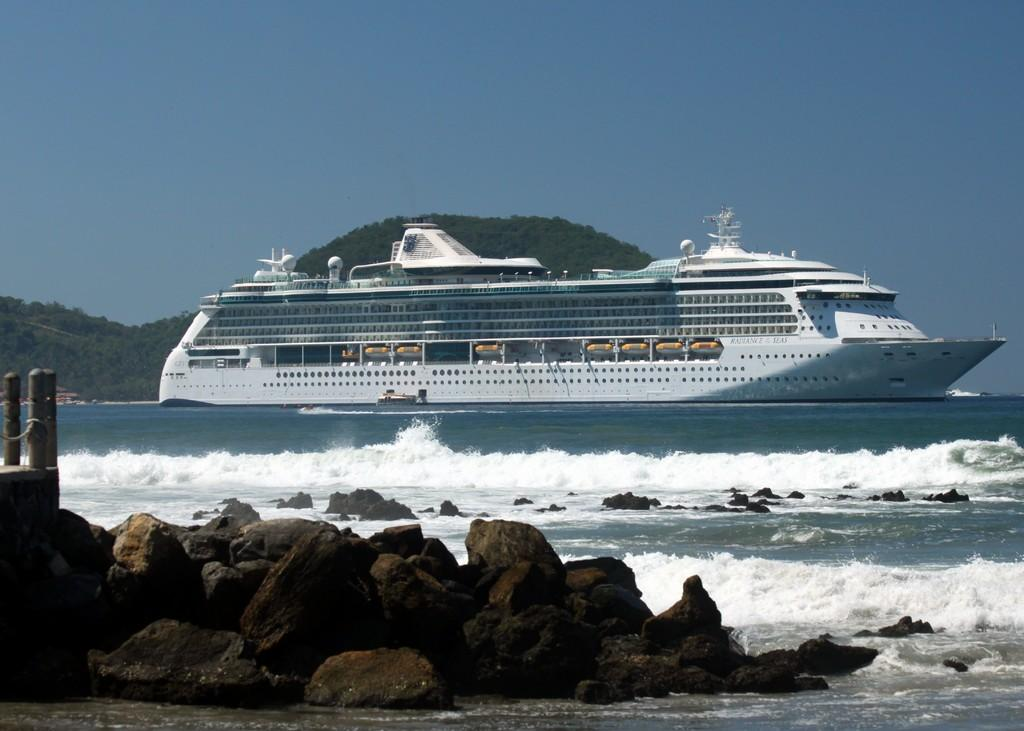What type of natural formation can be seen in the image? There are rocks in the image. What is located in the water in the image? There is a ship in the water in the image. What can be seen in the background of the image? There are hills and trees visible in the background of the image. Can you tell me how many squirrels are climbing on the rocks in the image? There are no squirrels present in the image; it features rocks, a ship, hills, and trees. What type of goat can be seen grazing on the hills in the image? There is no goat present in the image; it only features rocks, a ship, hills, and trees. 